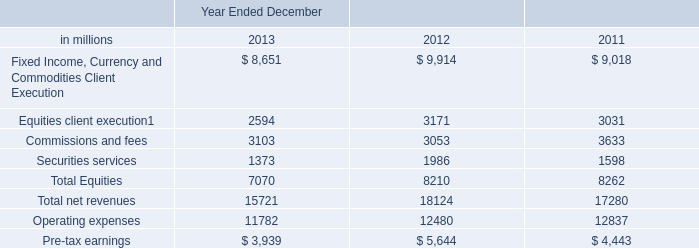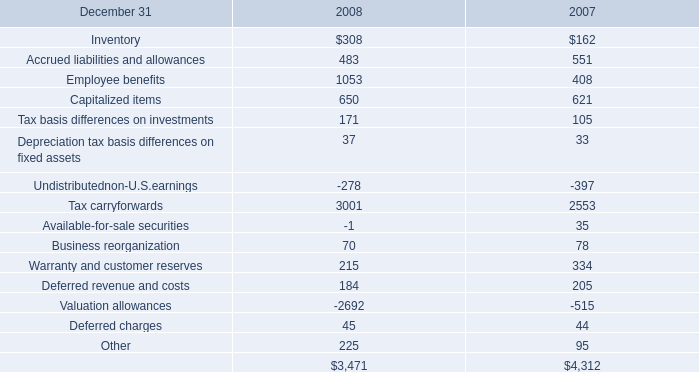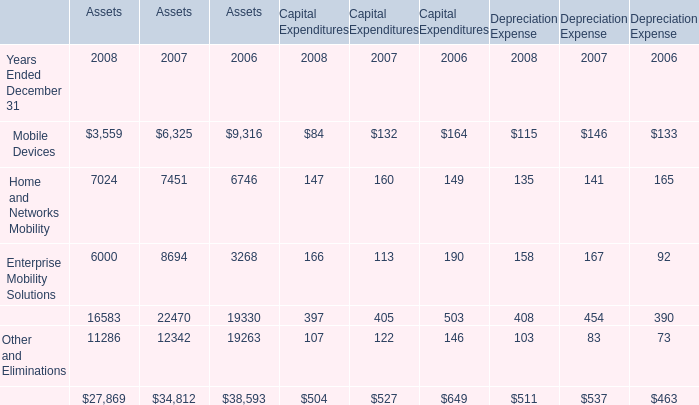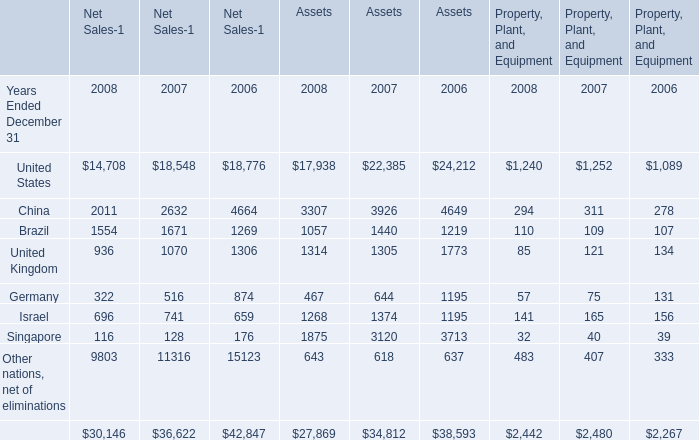What is the average value of Home and Networks Mobility in 2008,2007 and 2006 for Assets? 
Computations: (((7024 + 7451) + 6746) / 3)
Answer: 7073.66667. 